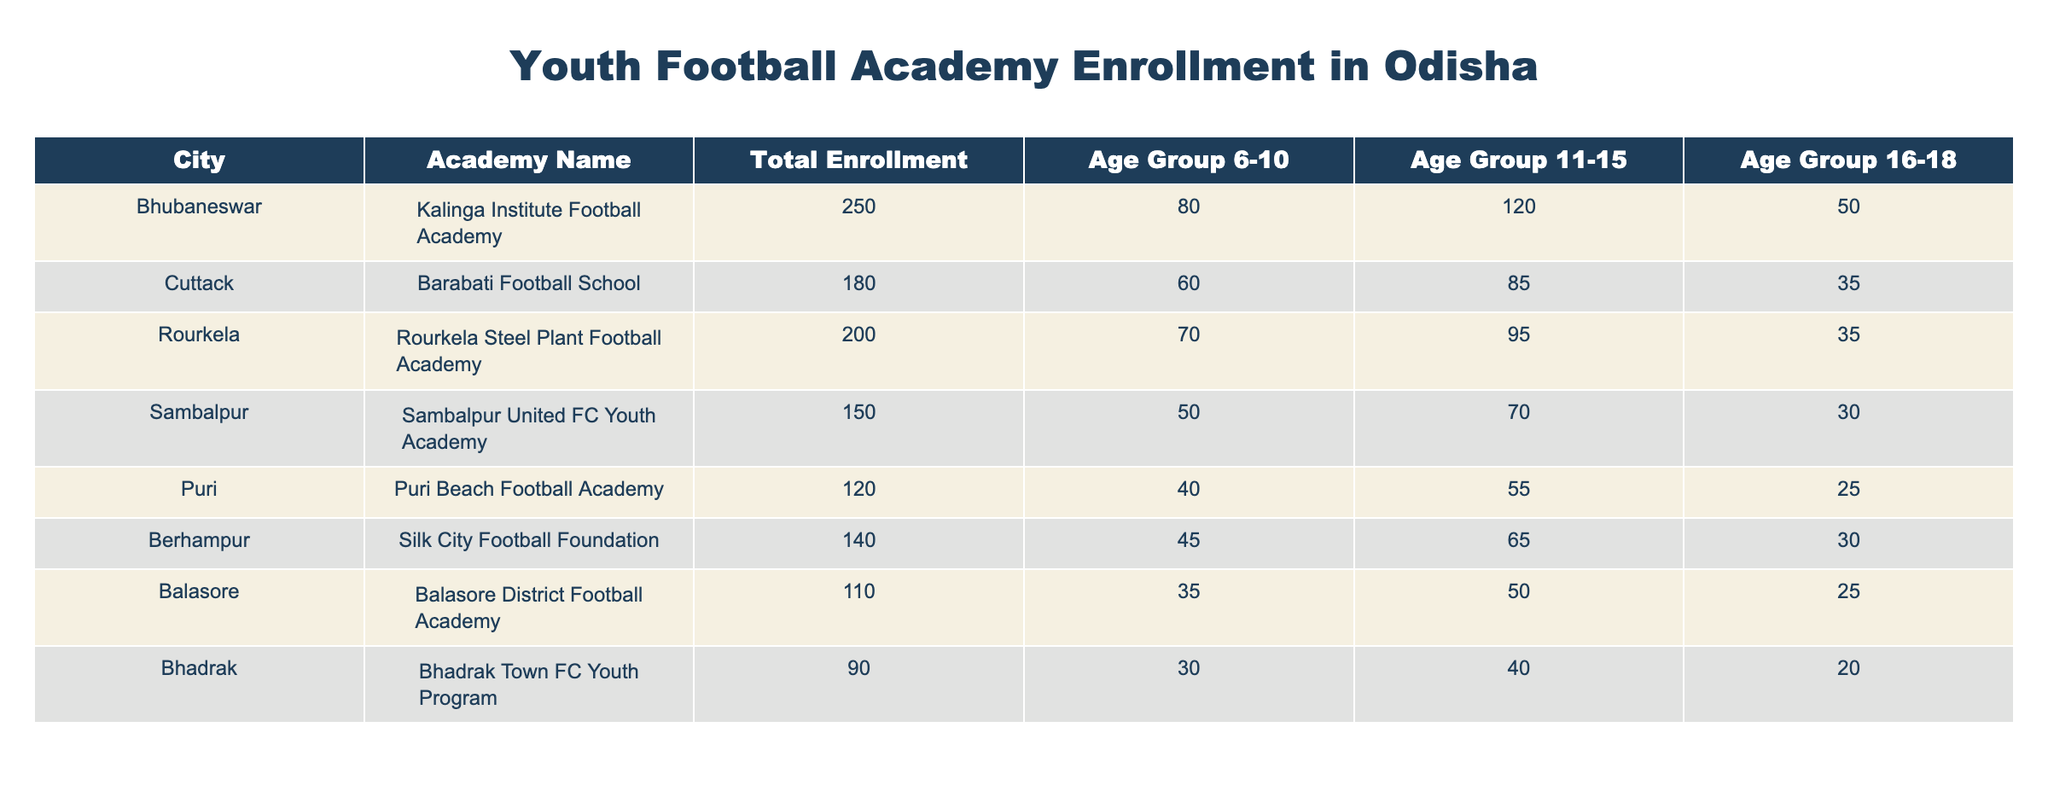What is the total enrollment for Kalinga Institute Football Academy in Bhubaneswar? The table shows that Kalinga Institute Football Academy has a total enrollment of 250.
Answer: 250 Which city has the highest enrollment in age group 11-15? By comparing the values for age group 11-15, Kalinga Institute Football Academy has the highest enrollment with 120 in Bhubaneswar.
Answer: Bhubaneswar What is the total enrollment for all academies in Cuttack and Rourkela combined? For Barabati Football School in Cuttack, the enrollment is 180, and for Rourkela Steel Plant Football Academy, it is 200. Summing these gives 180 + 200 = 380.
Answer: 380 Is the enrollment for Sambalpur United FC Youth Academy greater than that of Puri Beach Football Academy? The total enrollment for Sambalpur United FC Youth Academy is 150, while Puri Beach Football Academy has 120. Thus, yes, Sambalpur's enrollment is greater.
Answer: Yes What is the average enrollment across the four age groups for Balasore District Football Academy? The total enrollment for Balasore is 110. To find the average, we consider all age groups: 35 (6-10) + 50 (11-15) + 25 (16-18) = 110. As there are 3 groups, the average is 110/3 = 36.67.
Answer: 36.67 How many more students are enrolled in age group 16-18 compared to age group 6-10 for Rourkela Steel Plant Football Academy? For Rourkela Steel Plant Football Academy, the enrollment in age group 16-18 is 35, and in age group 6-10, it is 70. The difference is 70 - 35 = 35, thus there are 35 more students in age group 6-10.
Answer: 35 Which academy has the smallest total enrollment and what is that number? Reviewing the total enrollments, Balasore District Football Academy has the smallest enrollment with a total of 110.
Answer: 110 What is the total enrollment for the age group 6-10 across all listed academies in Odisha? Summing the 6-10 age group enrollments: 80 (Bhubaneswar) + 60 (Cuttack) + 70 (Rourkela) + 50 (Sambalpur) + 40 (Puri) + 45 (Berhampur) + 35 (Balasore) + 30 (Bhadrak) = 410.
Answer: 410 In which age group does Bhadrak Town FC Youth Program have the least enrollment? Bhadrak Town FC has the least enrollment in the age group 16-18, with 20 students compared to 30 in age 6-10 and 40 in age 11-15.
Answer: 16-18 